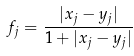<formula> <loc_0><loc_0><loc_500><loc_500>f _ { j } = \frac { | x _ { j } - y _ { j } | } { 1 + | x _ { j } - y _ { j } | }</formula> 